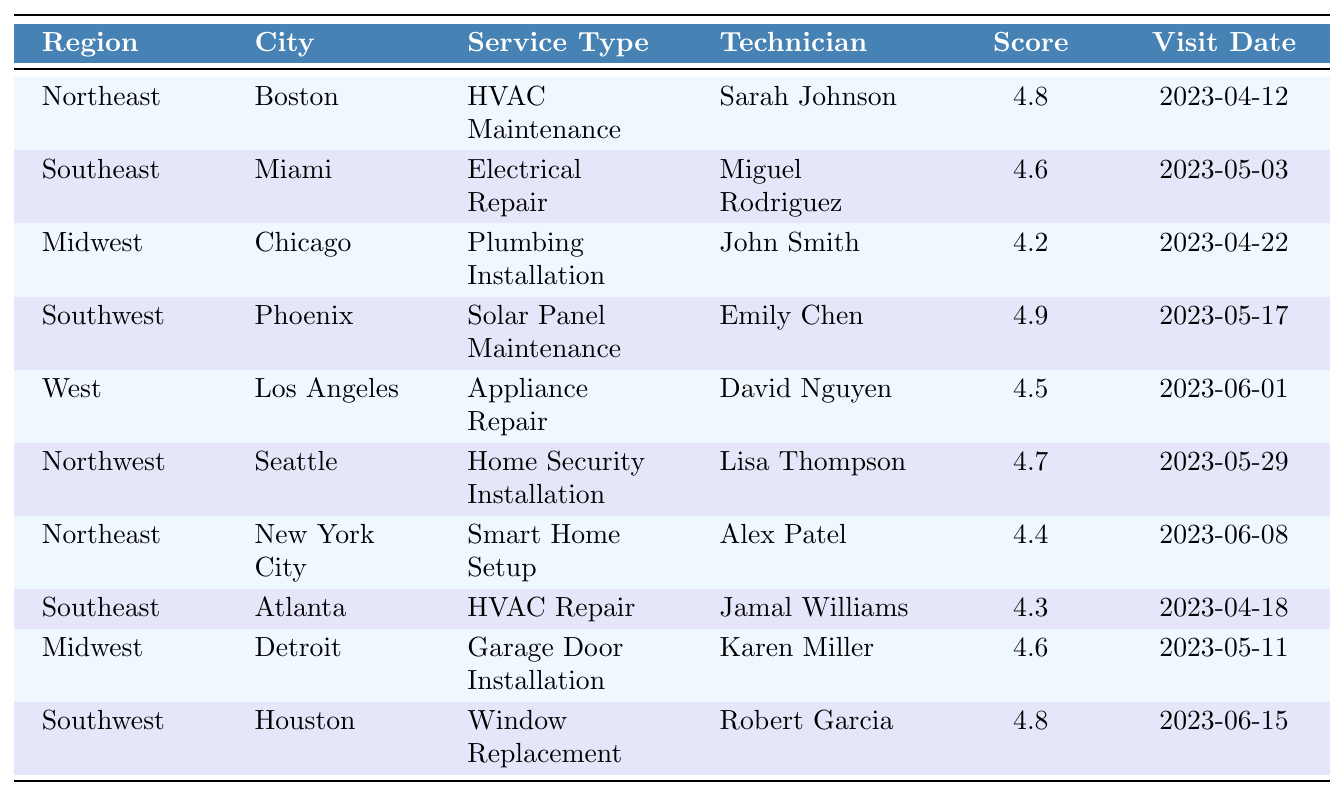What was the satisfaction score for the HVAC Maintenance service in Boston? The table shows that the satisfaction score for HVAC Maintenance in Boston is 4.8.
Answer: 4.8 Which region had the highest satisfaction score for any service type? The Southwest region had the highest satisfaction score of 4.9 for Solar Panel Maintenance.
Answer: Southwest What is the satisfaction score for the Electrical Repair service in Miami? From the table, the satisfaction score for Electrical Repair in Miami is 4.6.
Answer: 4.6 Did the technician Sarah Johnson receive a satisfaction score above 4.5? Yes, Sarah Johnson scored 4.8, which is above 4.5.
Answer: Yes What is the average satisfaction score across all the service visits in the table? The scores are 4.8, 4.6, 4.2, 4.9, 4.5, 4.7, 4.4, 4.3, 4.6, and 4.8. The sum of these scores is 46.8, and there are 10 scores, so the average is 46.8/10 = 4.68.
Answer: 4.68 Which technician had the lowest satisfaction score and what was that score? The lowest satisfaction score is 4.2, which was given to technician John Smith for Plumbing Installation in Chicago.
Answer: John Smith, 4.2 Are there any services with a satisfaction score of 4.3 or lower? Yes, the HVAC Repair service in Atlanta scored 4.3, which is lower than 4.3.
Answer: Yes How many technicians scored above 4.5? The technicians with scores above 4.5 are Sarah Johnson (4.8), Miguel Rodriguez (4.6), Emily Chen (4.9), David Nguyen (4.5), Lisa Thompson (4.7), Alex Patel (4.4), Karen Miller (4.6), and Robert Garcia (4.8). That's a total of 8 technicians.
Answer: 8 What service type had the second highest satisfaction score and what was that score? The second highest satisfaction score is 4.8 for the services Solar Panel Maintenance and Window Replacement, both from the Southwest region.
Answer: 4.8 Is there a service type that was performed in more than one city? HVAC Maintenance was performed in both Boston and Atlanta.
Answer: Yes What is the difference in satisfaction scores between the highest (4.9) and lowest (4.2) scores? The highest score is 4.9 (Solar Panel Maintenance) and the lowest is 4.2 (Plumbing Installation). The difference is 4.9 - 4.2 = 0.7.
Answer: 0.7 